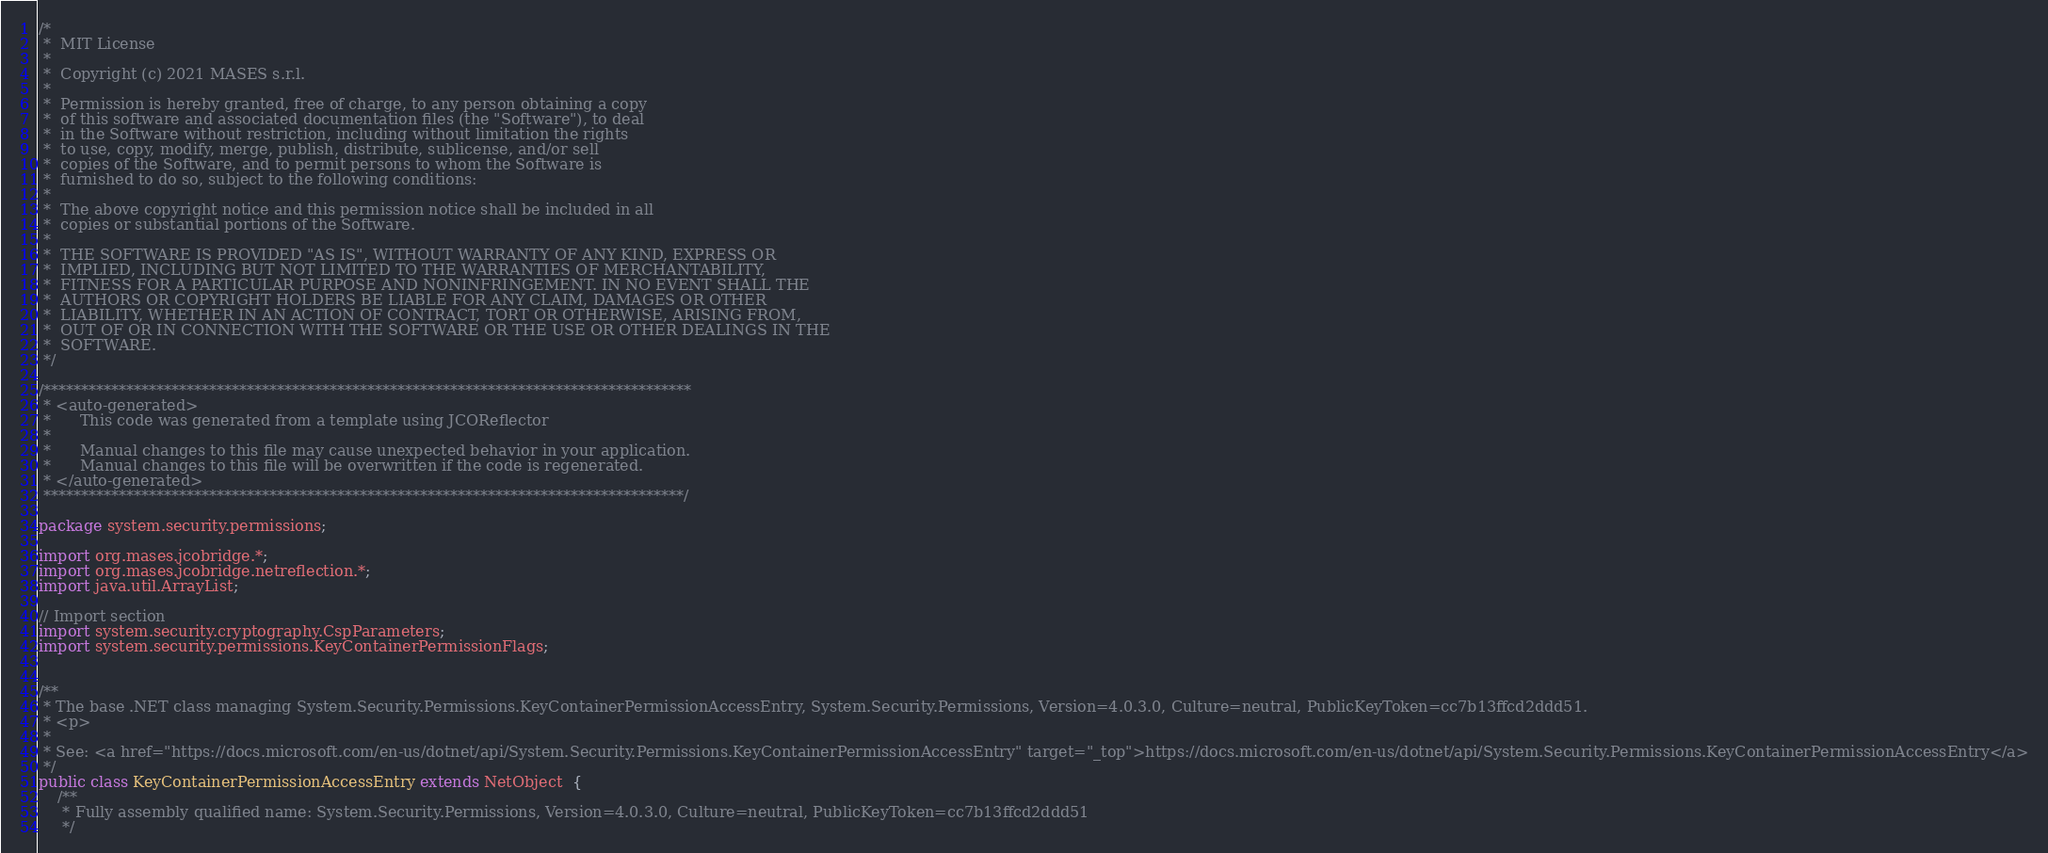<code> <loc_0><loc_0><loc_500><loc_500><_Java_>/*
 *  MIT License
 *
 *  Copyright (c) 2021 MASES s.r.l.
 *
 *  Permission is hereby granted, free of charge, to any person obtaining a copy
 *  of this software and associated documentation files (the "Software"), to deal
 *  in the Software without restriction, including without limitation the rights
 *  to use, copy, modify, merge, publish, distribute, sublicense, and/or sell
 *  copies of the Software, and to permit persons to whom the Software is
 *  furnished to do so, subject to the following conditions:
 *
 *  The above copyright notice and this permission notice shall be included in all
 *  copies or substantial portions of the Software.
 *
 *  THE SOFTWARE IS PROVIDED "AS IS", WITHOUT WARRANTY OF ANY KIND, EXPRESS OR
 *  IMPLIED, INCLUDING BUT NOT LIMITED TO THE WARRANTIES OF MERCHANTABILITY,
 *  FITNESS FOR A PARTICULAR PURPOSE AND NONINFRINGEMENT. IN NO EVENT SHALL THE
 *  AUTHORS OR COPYRIGHT HOLDERS BE LIABLE FOR ANY CLAIM, DAMAGES OR OTHER
 *  LIABILITY, WHETHER IN AN ACTION OF CONTRACT, TORT OR OTHERWISE, ARISING FROM,
 *  OUT OF OR IN CONNECTION WITH THE SOFTWARE OR THE USE OR OTHER DEALINGS IN THE
 *  SOFTWARE.
 */

/**************************************************************************************
 * <auto-generated>
 *      This code was generated from a template using JCOReflector
 * 
 *      Manual changes to this file may cause unexpected behavior in your application.
 *      Manual changes to this file will be overwritten if the code is regenerated.
 * </auto-generated>
 *************************************************************************************/

package system.security.permissions;

import org.mases.jcobridge.*;
import org.mases.jcobridge.netreflection.*;
import java.util.ArrayList;

// Import section
import system.security.cryptography.CspParameters;
import system.security.permissions.KeyContainerPermissionFlags;


/**
 * The base .NET class managing System.Security.Permissions.KeyContainerPermissionAccessEntry, System.Security.Permissions, Version=4.0.3.0, Culture=neutral, PublicKeyToken=cc7b13ffcd2ddd51.
 * <p>
 * 
 * See: <a href="https://docs.microsoft.com/en-us/dotnet/api/System.Security.Permissions.KeyContainerPermissionAccessEntry" target="_top">https://docs.microsoft.com/en-us/dotnet/api/System.Security.Permissions.KeyContainerPermissionAccessEntry</a>
 */
public class KeyContainerPermissionAccessEntry extends NetObject  {
    /**
     * Fully assembly qualified name: System.Security.Permissions, Version=4.0.3.0, Culture=neutral, PublicKeyToken=cc7b13ffcd2ddd51
     */</code> 